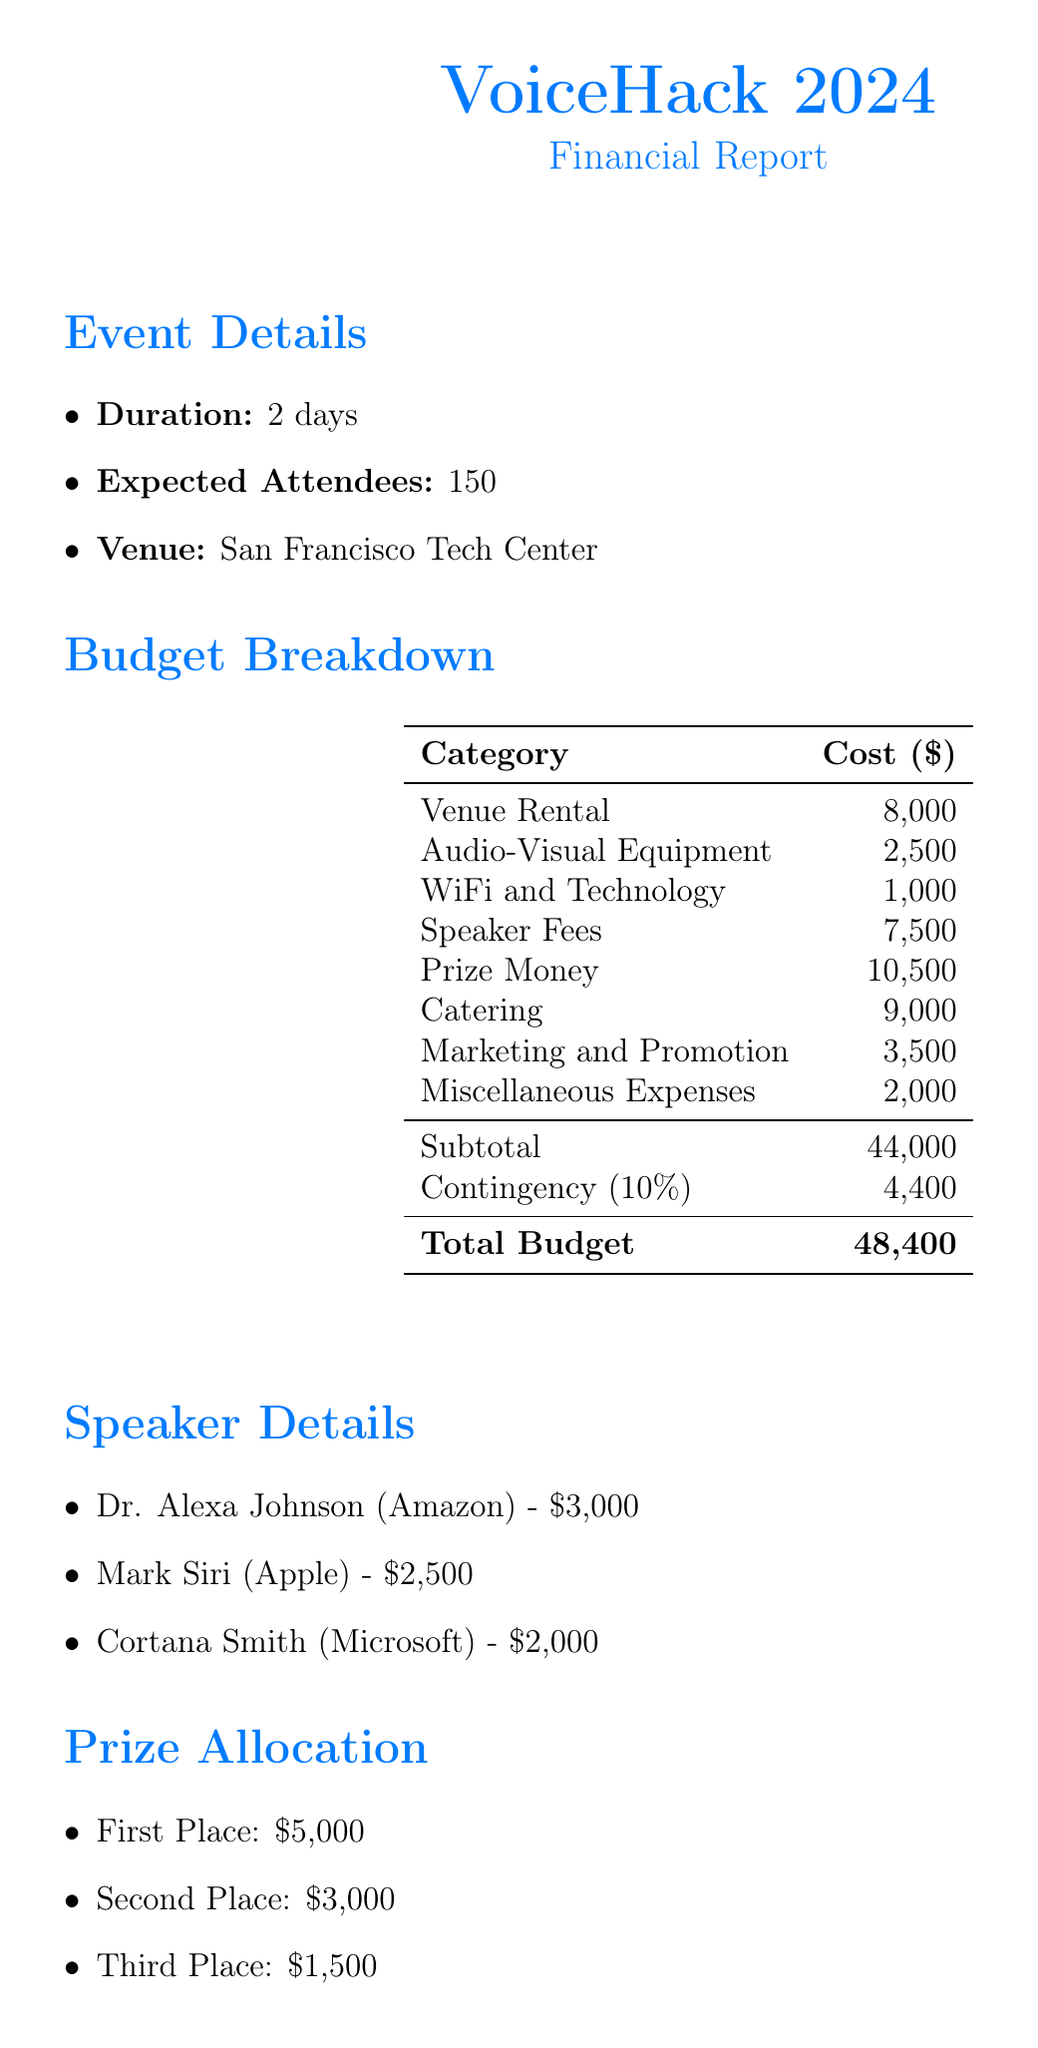What is the venue rental fee? The venue rental fee is listed as one of the costs in the budget breakdown.
Answer: 8,000 How much is the prize money for first place? The prize money allocation section specifies the amount allocated for the first place winner.
Answer: 5,000 What is the total number of expected attendees? The event details section provides the number of expected attendees for the event.
Answer: 150 What is the total cost for speaker fees? The total cost for speaker fees is the sum of the individual fees listed for each speaker.
Answer: 7,500 What is the catering cost based on per meal per day? The document states the catering costs are based on a specific amount per meal per day for attendees.
Answer: 30 What percentage of the total budget is the contingency fund? The budget includes a line specifying the contingency fund as a percentage of the total amount.
Answer: 10% How many days will the event last? The event duration is clearly stated in the event details section.
Answer: 2 days What is the total budget including the contingency? The budget breakdown provides the subtotal and adds the contingency to show the total budget amount.
Answer: 48,400 What is the total prize money allocation? The prize money allocation lists the amounts for various positions, and combining them gives a total.
Answer: 10,500 